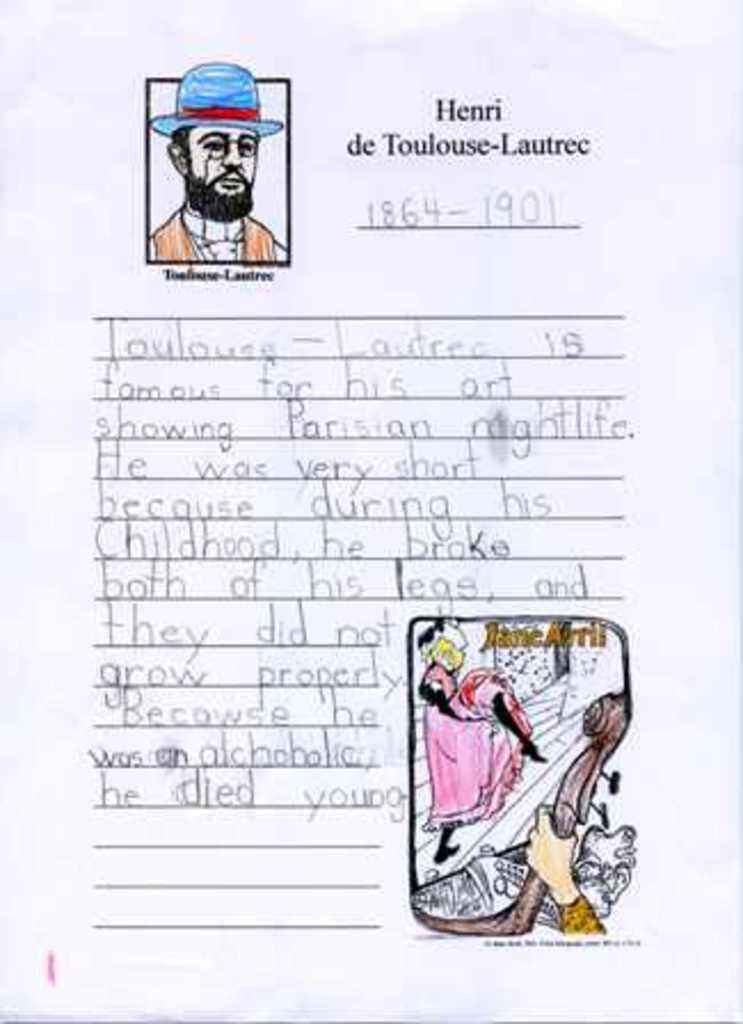Describe this image in one or two sentences. In this image I can see a paper which is white in color and on it I can see a picture of a person and picture of a woman wearing pink colored dress. I can see something is written on the paper with pencil. 